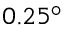Convert formula to latex. <formula><loc_0><loc_0><loc_500><loc_500>0 . 2 5 ^ { \circ }</formula> 